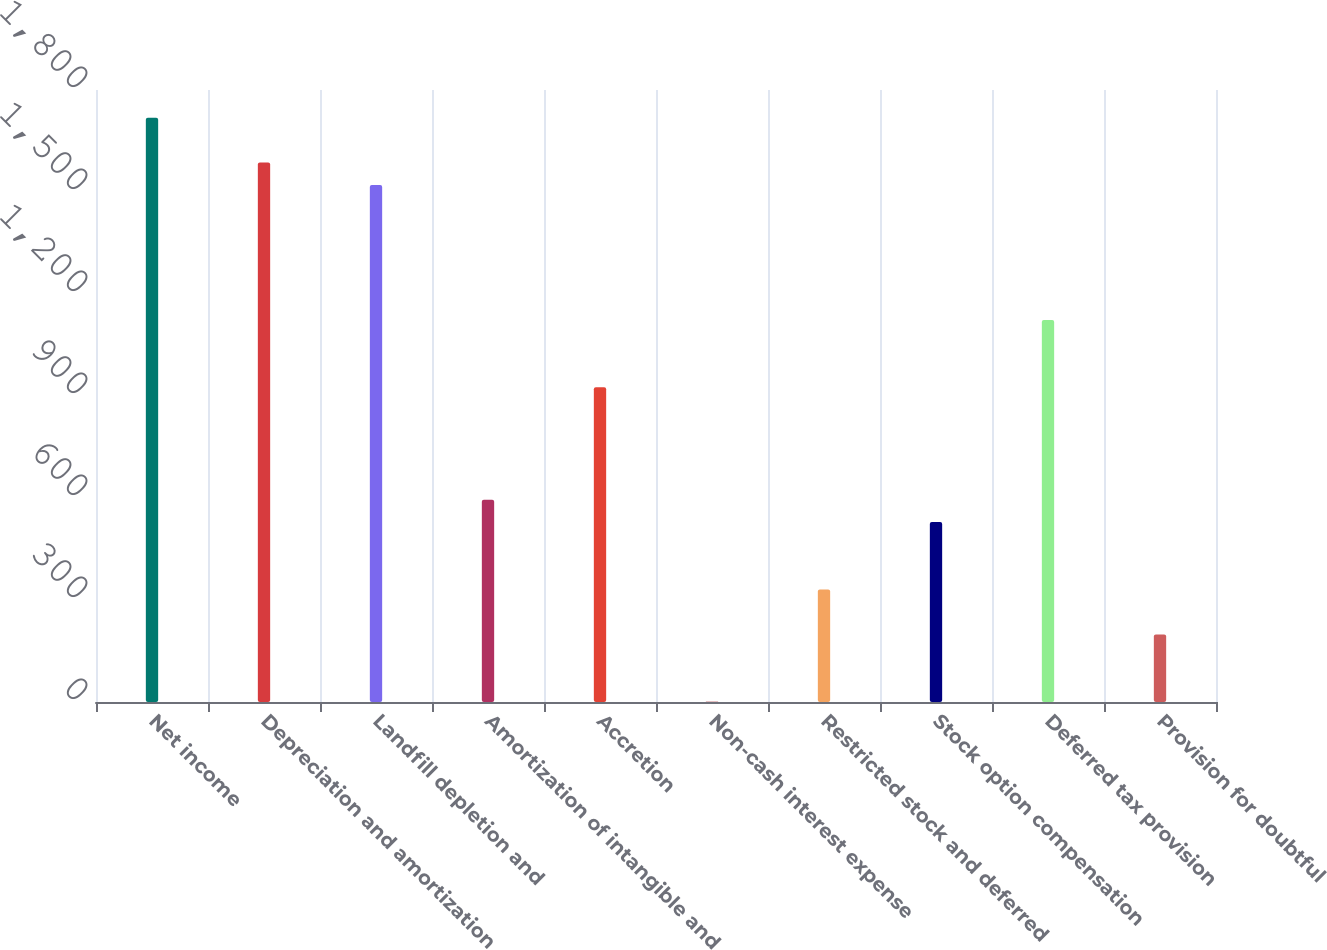Convert chart to OTSL. <chart><loc_0><loc_0><loc_500><loc_500><bar_chart><fcel>Net income<fcel>Depreciation and amortization<fcel>Landfill depletion and<fcel>Amortization of intangible and<fcel>Accretion<fcel>Non-cash interest expense<fcel>Restricted stock and deferred<fcel>Stock option compensation<fcel>Deferred tax provision<fcel>Provision for doubtful<nl><fcel>1718.58<fcel>1586.42<fcel>1520.34<fcel>595.22<fcel>925.62<fcel>0.5<fcel>330.9<fcel>529.14<fcel>1123.86<fcel>198.74<nl></chart> 